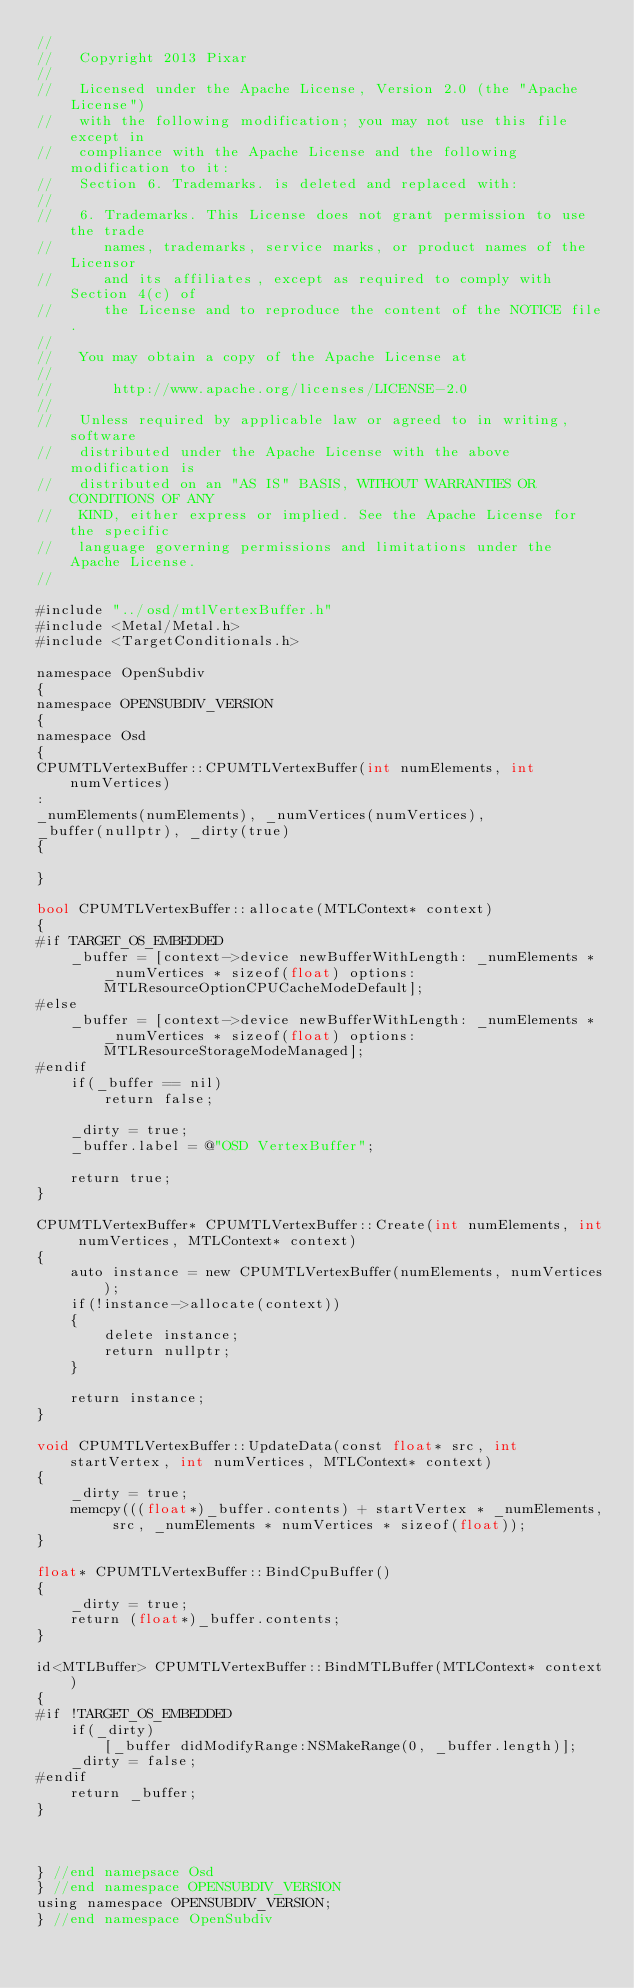Convert code to text. <code><loc_0><loc_0><loc_500><loc_500><_ObjectiveC_>//
//   Copyright 2013 Pixar
//
//   Licensed under the Apache License, Version 2.0 (the "Apache License")
//   with the following modification; you may not use this file except in
//   compliance with the Apache License and the following modification to it:
//   Section 6. Trademarks. is deleted and replaced with:
//
//   6. Trademarks. This License does not grant permission to use the trade
//      names, trademarks, service marks, or product names of the Licensor
//      and its affiliates, except as required to comply with Section 4(c) of
//      the License and to reproduce the content of the NOTICE file.
//
//   You may obtain a copy of the Apache License at
//
//       http://www.apache.org/licenses/LICENSE-2.0
//
//   Unless required by applicable law or agreed to in writing, software
//   distributed under the Apache License with the above modification is
//   distributed on an "AS IS" BASIS, WITHOUT WARRANTIES OR CONDITIONS OF ANY
//   KIND, either express or implied. See the Apache License for the specific
//   language governing permissions and limitations under the Apache License.
//

#include "../osd/mtlVertexBuffer.h"
#include <Metal/Metal.h>
#include <TargetConditionals.h>

namespace OpenSubdiv
{
namespace OPENSUBDIV_VERSION
{
namespace Osd
{
CPUMTLVertexBuffer::CPUMTLVertexBuffer(int numElements, int numVertices)
:
_numElements(numElements), _numVertices(numVertices),
_buffer(nullptr), _dirty(true)
{

}

bool CPUMTLVertexBuffer::allocate(MTLContext* context)
{
#if TARGET_OS_EMBEDDED
    _buffer = [context->device newBufferWithLength: _numElements * _numVertices * sizeof(float) options:MTLResourceOptionCPUCacheModeDefault];
#else
    _buffer = [context->device newBufferWithLength: _numElements * _numVertices * sizeof(float) options:MTLResourceStorageModeManaged];
#endif
    if(_buffer == nil)
        return false;

    _dirty = true;
    _buffer.label = @"OSD VertexBuffer";

    return true;
}

CPUMTLVertexBuffer* CPUMTLVertexBuffer::Create(int numElements, int numVertices, MTLContext* context)
{
    auto instance = new CPUMTLVertexBuffer(numElements, numVertices);
    if(!instance->allocate(context))
    {
        delete instance;
        return nullptr;
    }

    return instance;
}

void CPUMTLVertexBuffer::UpdateData(const float* src, int startVertex, int numVertices, MTLContext* context)
{
    _dirty = true;
    memcpy(((float*)_buffer.contents) + startVertex * _numElements, src, _numElements * numVertices * sizeof(float));
}

float* CPUMTLVertexBuffer::BindCpuBuffer()
{
    _dirty = true;
    return (float*)_buffer.contents;
}

id<MTLBuffer> CPUMTLVertexBuffer::BindMTLBuffer(MTLContext* context)
{
#if !TARGET_OS_EMBEDDED
    if(_dirty) 
        [_buffer didModifyRange:NSMakeRange(0, _buffer.length)];
    _dirty = false;
#endif
    return _buffer;
}



} //end namepsace Osd
} //end namespace OPENSUBDIV_VERSION
using namespace OPENSUBDIV_VERSION;
} //end namespace OpenSubdiv
</code> 